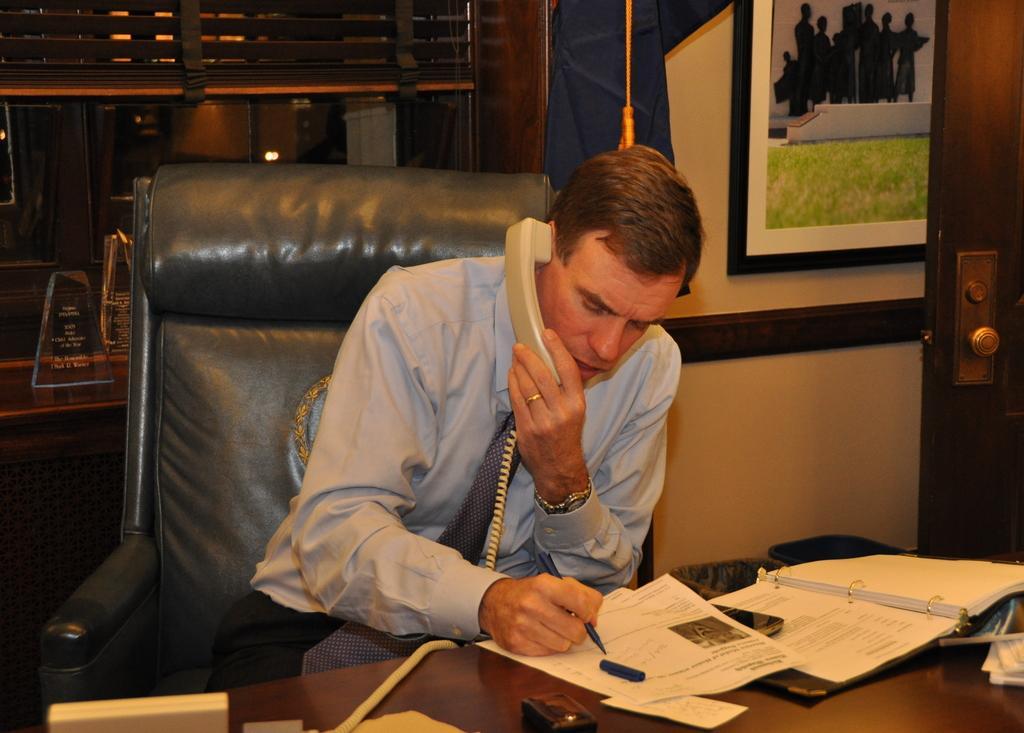Could you give a brief overview of what you see in this image? In this picture we can see a man who is sitting on the chair. He is talking on the phone. This is table. On the table there is a file, and papers. On the background we can see a wall and this is frame. And there is a door. 